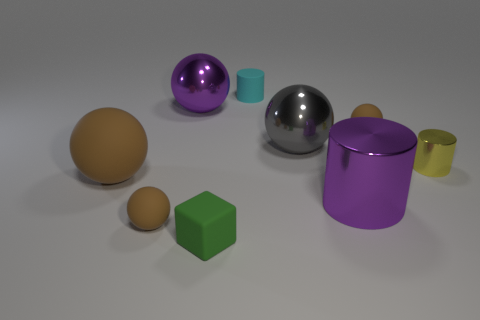Subtract all small spheres. How many spheres are left? 3 Subtract all green cylinders. How many brown spheres are left? 3 Subtract 1 cylinders. How many cylinders are left? 2 Subtract all purple spheres. How many spheres are left? 4 Add 1 brown rubber spheres. How many objects exist? 10 Subtract all blocks. How many objects are left? 8 Subtract all large gray things. Subtract all tiny green things. How many objects are left? 7 Add 7 small matte cylinders. How many small matte cylinders are left? 8 Add 1 large purple balls. How many large purple balls exist? 2 Subtract 0 yellow spheres. How many objects are left? 9 